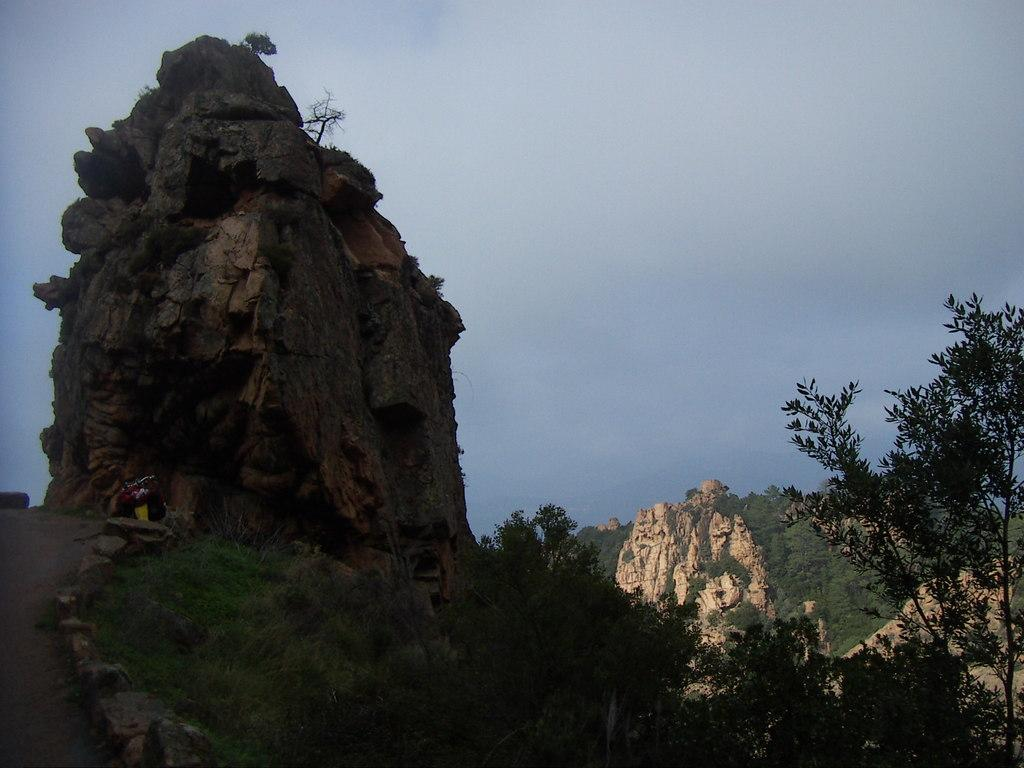What type of natural elements can be seen in the image? There are rocks, trees, grass, and plants visible in the image. What man-made feature is present in the image? There is a walkway in the image. What is visible in the background of the image? The sky is visible in the background of the image. What is the riddle that the rocks are trying to solve in the image? There is no riddle present in the image; the rocks are not depicted as having any such activity. Who is the owner of the trees in the image? There is no indication of ownership in the image, and the trees are not depicted as belonging to any specific person. 